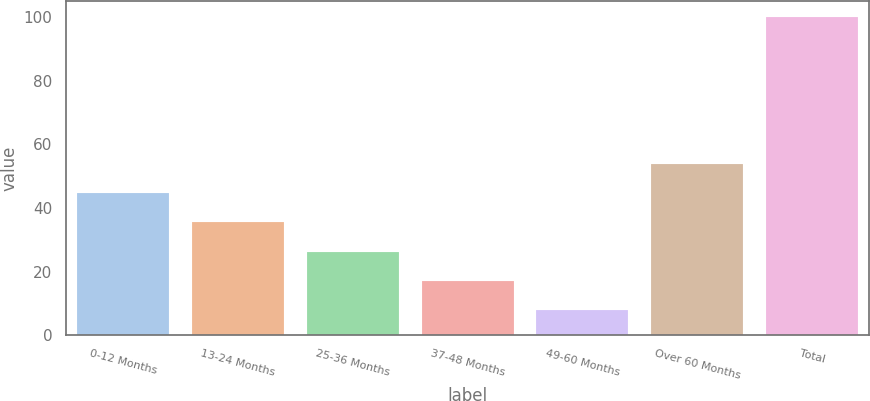<chart> <loc_0><loc_0><loc_500><loc_500><bar_chart><fcel>0-12 Months<fcel>13-24 Months<fcel>25-36 Months<fcel>37-48 Months<fcel>49-60 Months<fcel>Over 60 Months<fcel>Total<nl><fcel>44.74<fcel>35.53<fcel>26.32<fcel>17.11<fcel>7.9<fcel>53.95<fcel>100<nl></chart> 